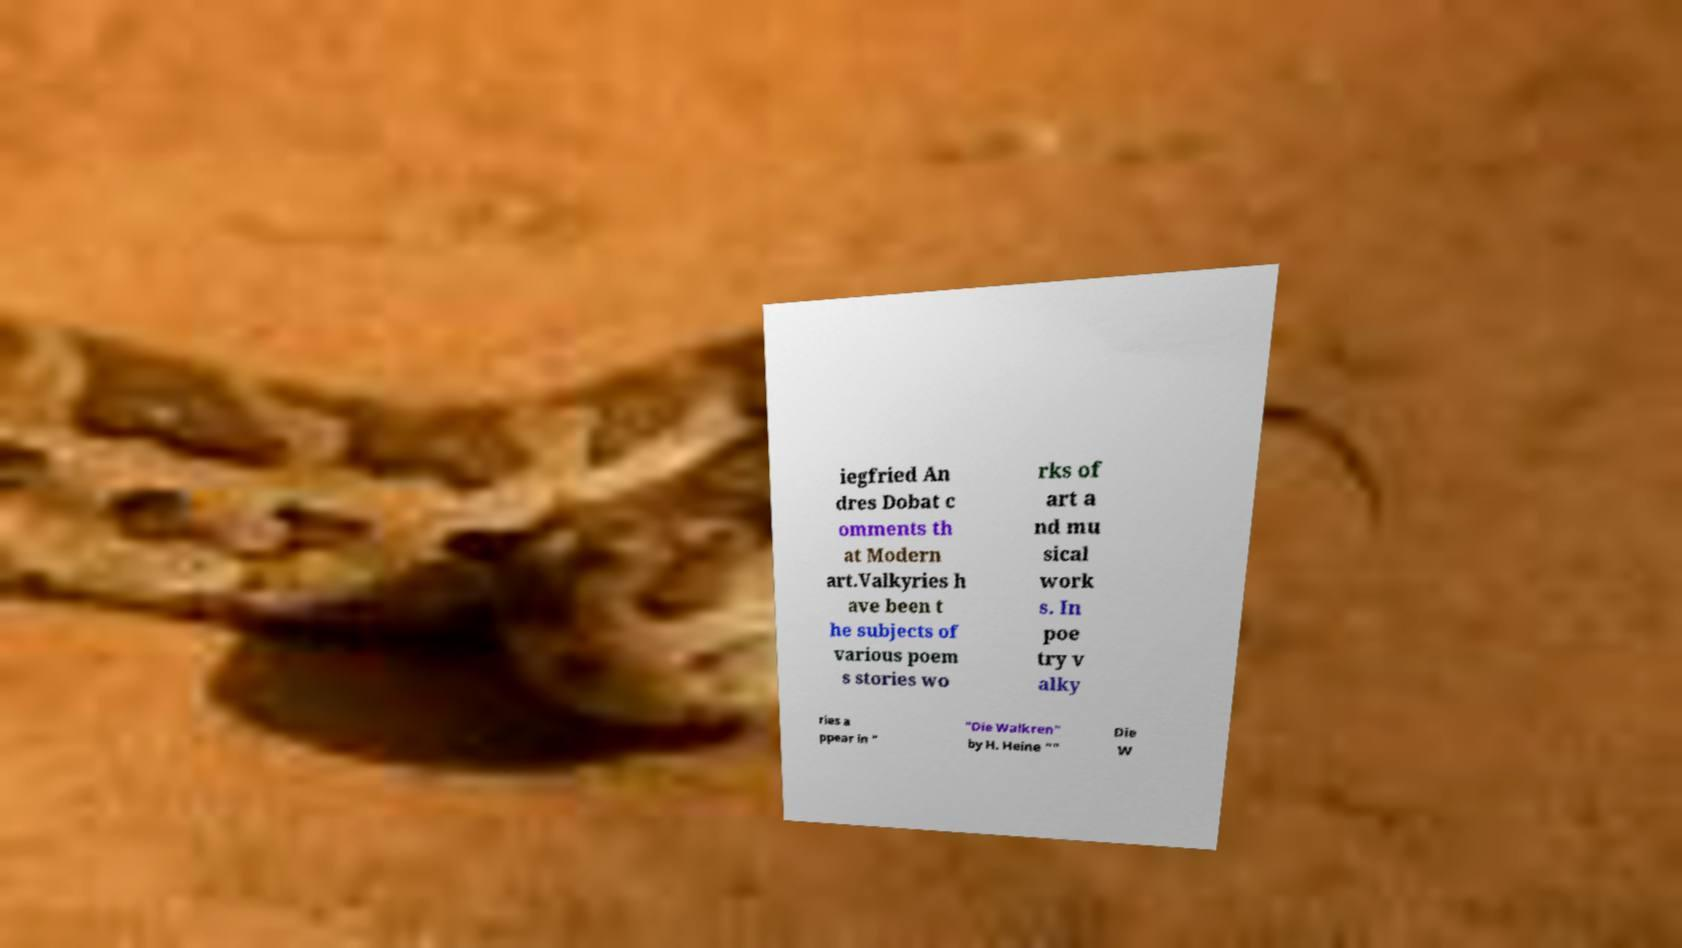Please identify and transcribe the text found in this image. iegfried An dres Dobat c omments th at Modern art.Valkyries h ave been t he subjects of various poem s stories wo rks of art a nd mu sical work s. In poe try v alky ries a ppear in " "Die Walkren" by H. Heine "" Die W 